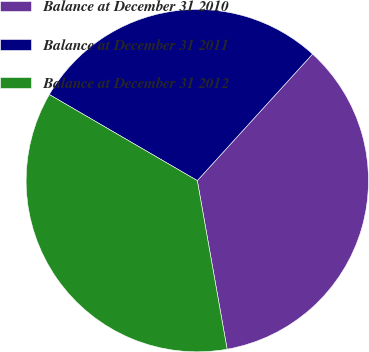Convert chart to OTSL. <chart><loc_0><loc_0><loc_500><loc_500><pie_chart><fcel>Balance at December 31 2010<fcel>Balance at December 31 2011<fcel>Balance at December 31 2012<nl><fcel>35.46%<fcel>28.37%<fcel>36.17%<nl></chart> 